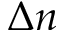<formula> <loc_0><loc_0><loc_500><loc_500>\Delta n</formula> 